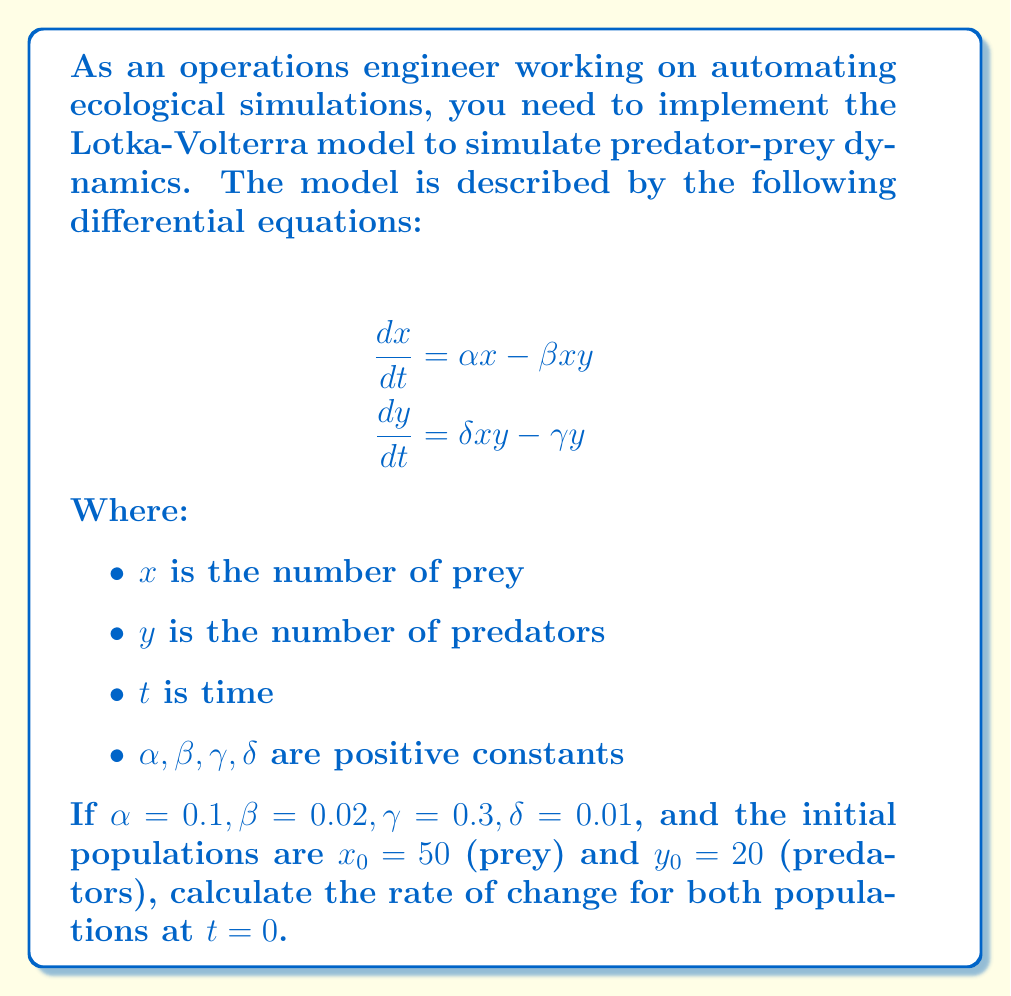Give your solution to this math problem. To solve this problem, we need to follow these steps:

1. Understand the Lotka-Volterra equations:
   - $\frac{dx}{dt}$ represents the rate of change of the prey population
   - $\frac{dy}{dt}$ represents the rate of change of the predator population

2. Substitute the given values into the equations:
   - $\alpha = 0.1$
   - $\beta = 0.02$
   - $\gamma = 0.3$
   - $\delta = 0.01$
   - $x_0 = 50$ (initial prey population)
   - $y_0 = 20$ (initial predator population)

3. Calculate $\frac{dx}{dt}$ at $t = 0$:
   $$\frac{dx}{dt} = \alpha x - \beta xy$$
   $$\frac{dx}{dt} = (0.1 \times 50) - (0.02 \times 50 \times 20)$$
   $$\frac{dx}{dt} = 5 - 20 = -15$$

4. Calculate $\frac{dy}{dt}$ at $t = 0$:
   $$\frac{dy}{dt} = \delta xy - \gamma y$$
   $$\frac{dy}{dt} = (0.01 \times 50 \times 20) - (0.3 \times 20)$$
   $$\frac{dy}{dt} = 10 - 6 = 4$$

5. Interpret the results:
   - The negative value for $\frac{dx}{dt}$ indicates that the prey population is decreasing at $t = 0$.
   - The positive value for $\frac{dy}{dt}$ indicates that the predator population is increasing at $t = 0$.
Answer: $\frac{dx}{dt} = -15, \frac{dy}{dt} = 4$ 